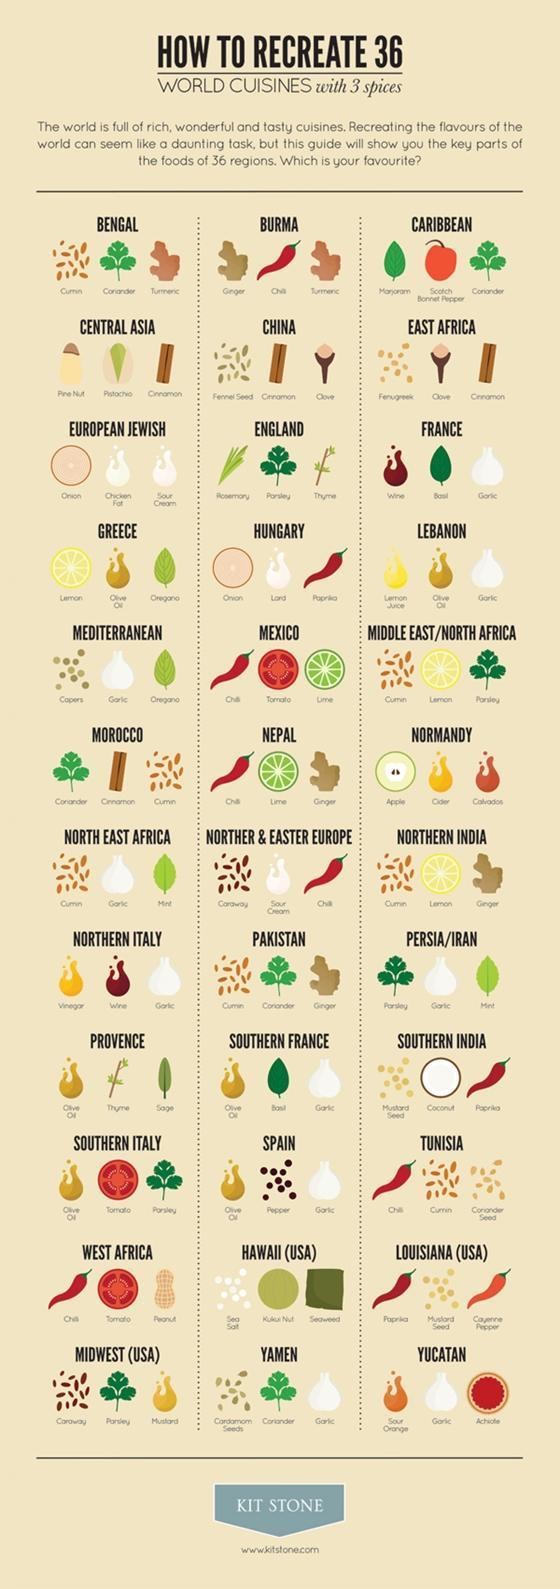Which are the ingredients are common to Bengal and Pakistan?
Answer the question with a short phrase. Cumin, Coriander Which two countries or regions make use of Tamarind? Bengal, Burma Which countries or regions use red wine for their cuisine? France, Northern Italy How many countries use red Paprika in their cuisine? 9 Which is the ingredient common to Mexico, Southern Italy and West Africa? Tomato How many regions use olive oil in their cuisines extensively? 6 How many regions use mint for their cooking ? 4 How many regions from India in the list of world cuisines? 3 